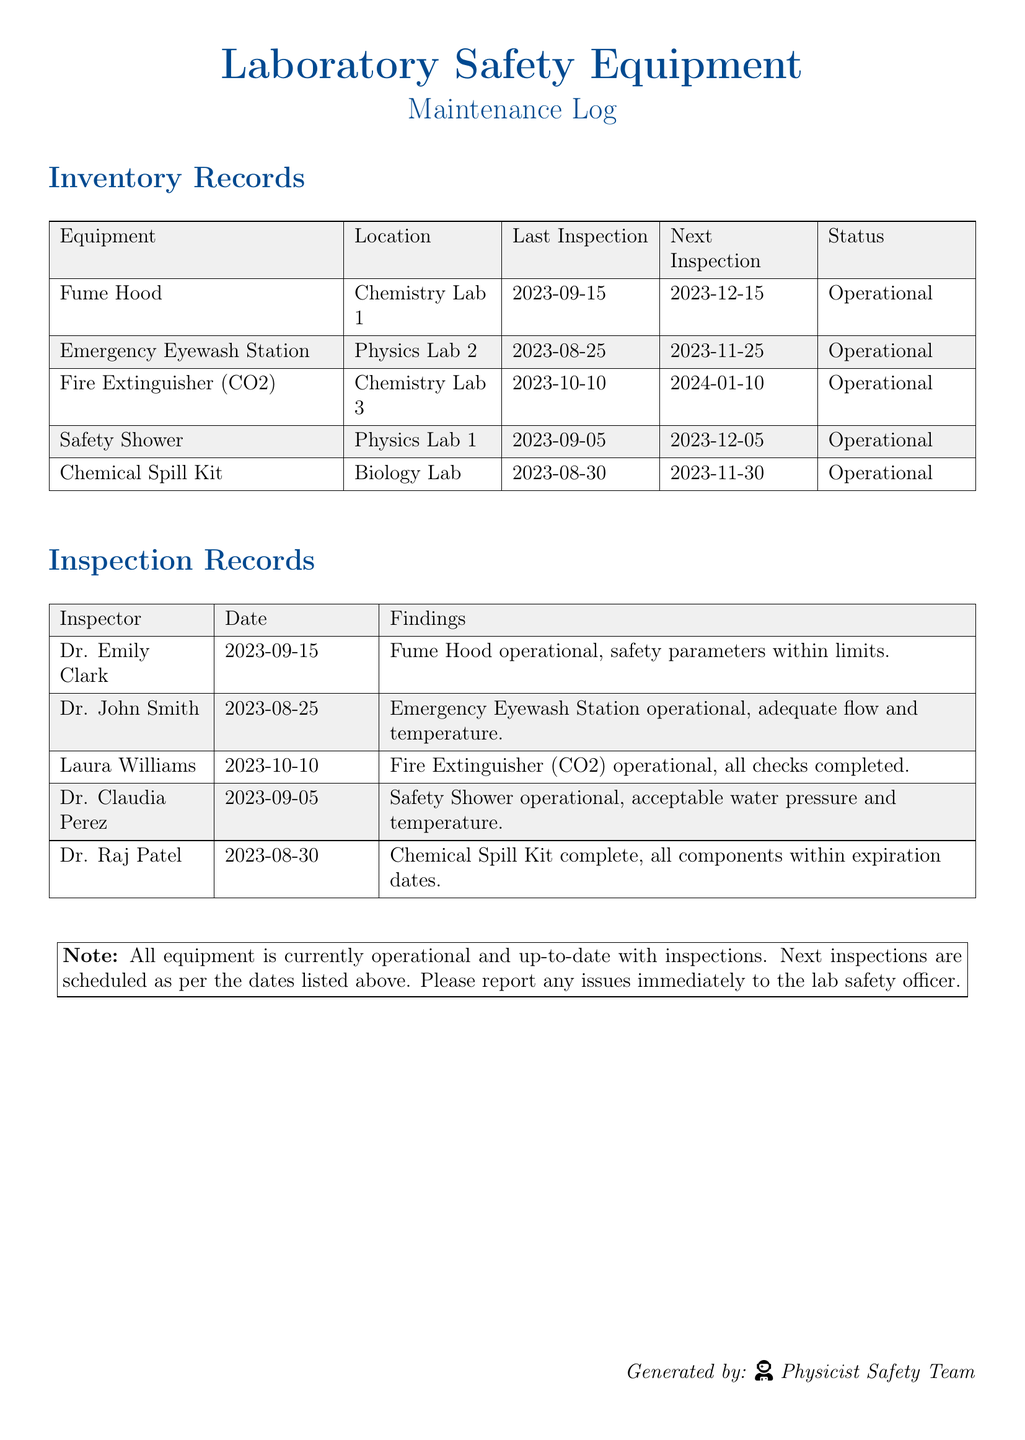What is the last inspection date for the Fume Hood? The last inspection date for the Fume Hood is provided in the Inventory Records section.
Answer: 2023-09-15 What is the status of the Safety Shower? The status of the Safety Shower can be found in the Inventory Records section.
Answer: Operational Who inspected the Emergency Eyewash Station? The inspector's name for the Emergency Eyewash Station is listed in the Inspection Records section.
Answer: Dr. John Smith When is the next inspection for the Chemical Spill Kit? The next inspection date for the Chemical Spill Kit is included in the Inventory Records.
Answer: 2023-11-30 What were the findings of Dr. Claudia Perez? The findings are detailed under the Inspection Records section where Dr. Claudia Perez's evaluation is noted.
Answer: Safety Shower operational, acceptable water pressure and temperature How many pieces of equipment are listed as operational? This is calculated by counting the entries under the Status column in the Inventory Records.
Answer: Five What is the location of the Fire Extinguisher (CO2)? The location of the Fire Extinguisher is found in the Inventory Records section.
Answer: Chemistry Lab 3 When is the next inspection for the Emergency Eyewash Station? The next inspection date is found in the Inventory Records for that specific equipment.
Answer: 2023-11-25 Is there a note about the operational status of the equipment? Information regarding operational status is summarized in a note at the end of the document.
Answer: Yes 